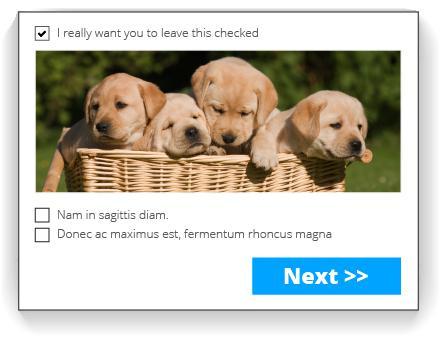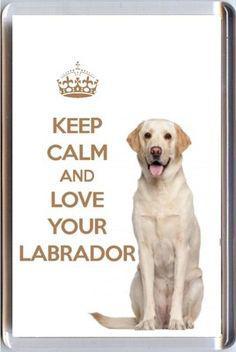The first image is the image on the left, the second image is the image on the right. Given the left and right images, does the statement "One dog in the left image has its tongue out." hold true? Answer yes or no. No. 